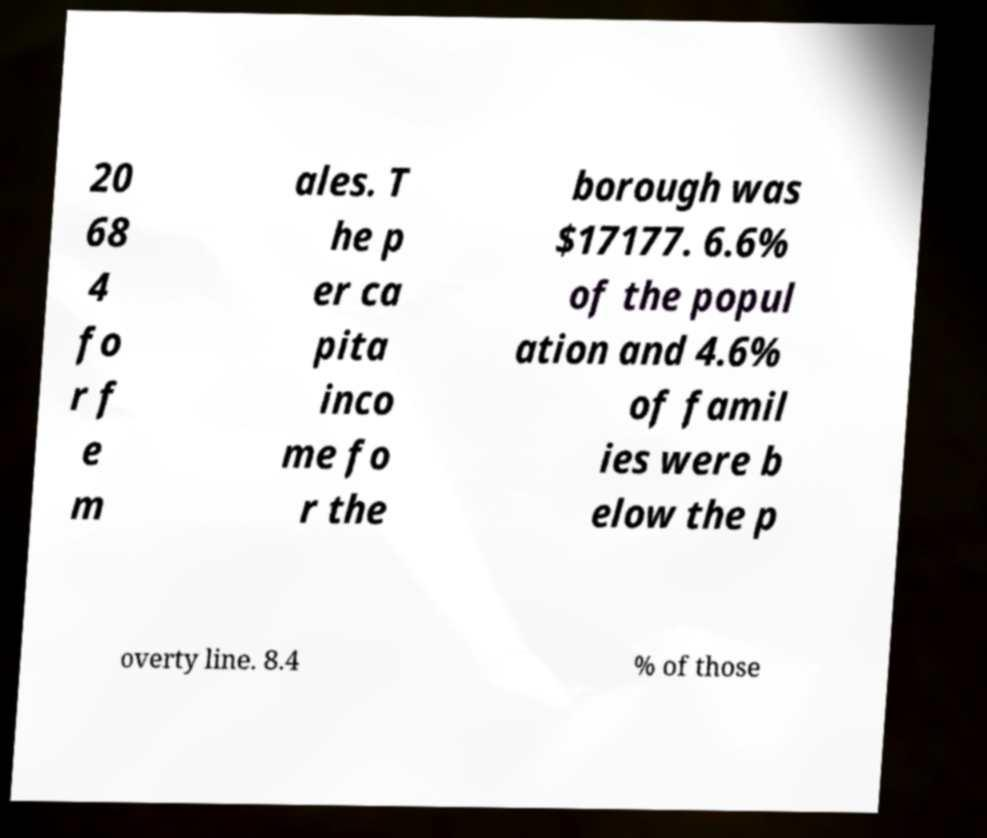I need the written content from this picture converted into text. Can you do that? 20 68 4 fo r f e m ales. T he p er ca pita inco me fo r the borough was $17177. 6.6% of the popul ation and 4.6% of famil ies were b elow the p overty line. 8.4 % of those 